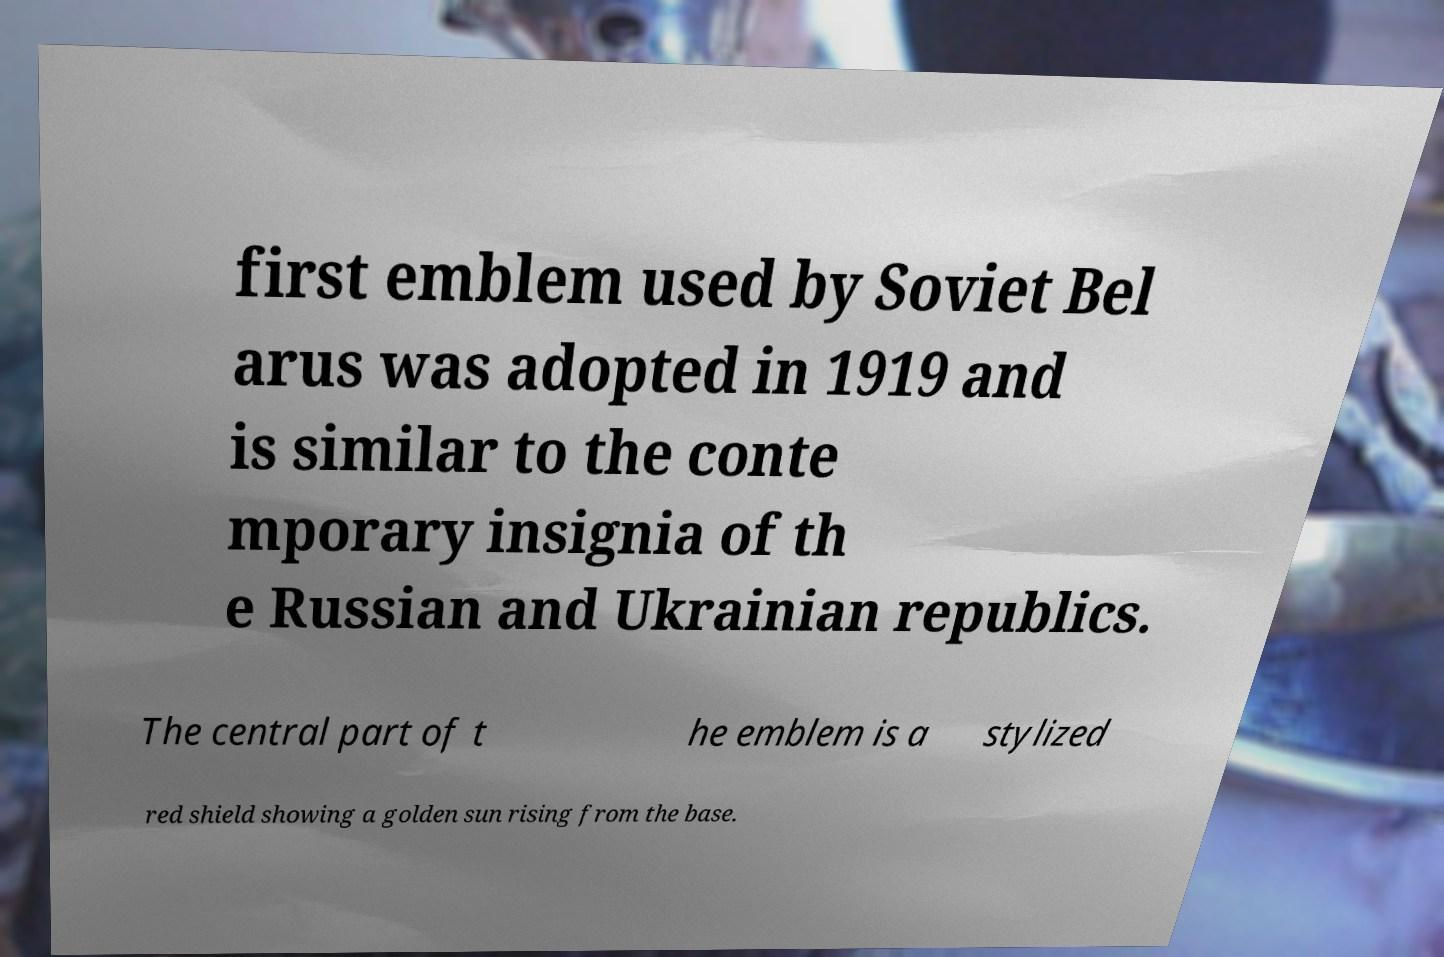There's text embedded in this image that I need extracted. Can you transcribe it verbatim? first emblem used by Soviet Bel arus was adopted in 1919 and is similar to the conte mporary insignia of th e Russian and Ukrainian republics. The central part of t he emblem is a stylized red shield showing a golden sun rising from the base. 